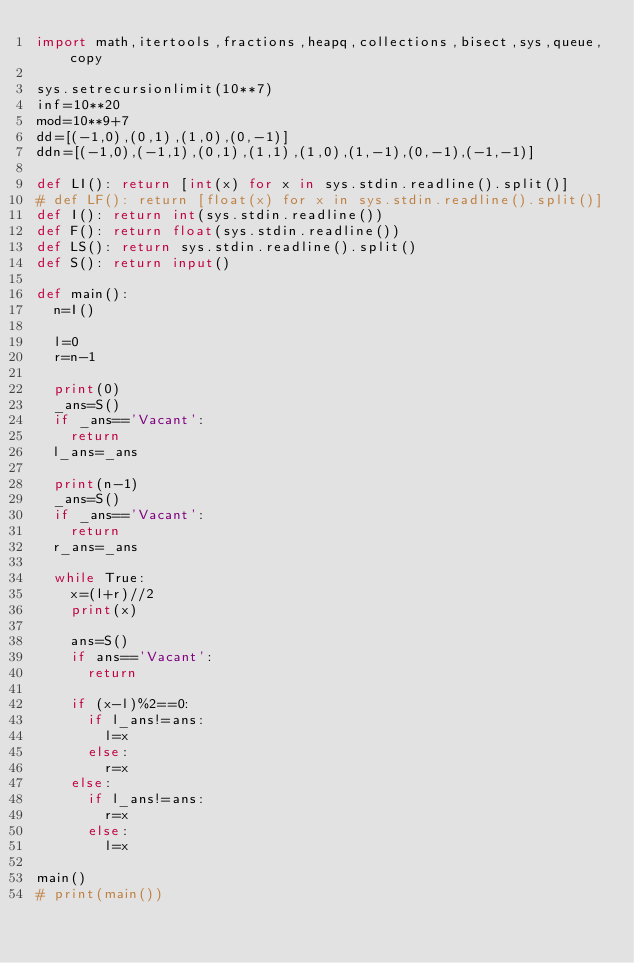Convert code to text. <code><loc_0><loc_0><loc_500><loc_500><_Python_>import math,itertools,fractions,heapq,collections,bisect,sys,queue,copy

sys.setrecursionlimit(10**7)
inf=10**20
mod=10**9+7
dd=[(-1,0),(0,1),(1,0),(0,-1)]
ddn=[(-1,0),(-1,1),(0,1),(1,1),(1,0),(1,-1),(0,-1),(-1,-1)]

def LI(): return [int(x) for x in sys.stdin.readline().split()]
# def LF(): return [float(x) for x in sys.stdin.readline().split()]
def I(): return int(sys.stdin.readline())
def F(): return float(sys.stdin.readline())
def LS(): return sys.stdin.readline().split()
def S(): return input()

def main():
  n=I()

  l=0
  r=n-1

  print(0)
  _ans=S()
  if _ans=='Vacant':
    return
  l_ans=_ans

  print(n-1)
  _ans=S()
  if _ans=='Vacant':
    return
  r_ans=_ans

  while True:
    x=(l+r)//2
    print(x)

    ans=S()
    if ans=='Vacant':
      return

    if (x-l)%2==0:
      if l_ans!=ans:
        l=x
      else:
        r=x
    else:
      if l_ans!=ans:
        r=x
      else:
        l=x

main()
# print(main())
</code> 